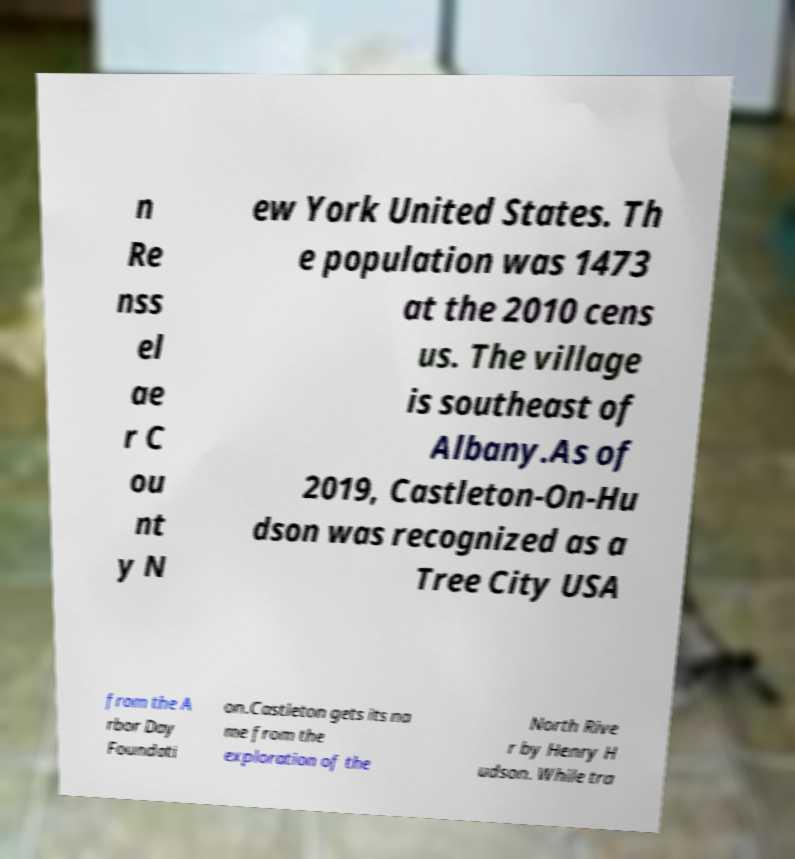I need the written content from this picture converted into text. Can you do that? n Re nss el ae r C ou nt y N ew York United States. Th e population was 1473 at the 2010 cens us. The village is southeast of Albany.As of 2019, Castleton-On-Hu dson was recognized as a Tree City USA from the A rbor Day Foundati on.Castleton gets its na me from the exploration of the North Rive r by Henry H udson. While tra 